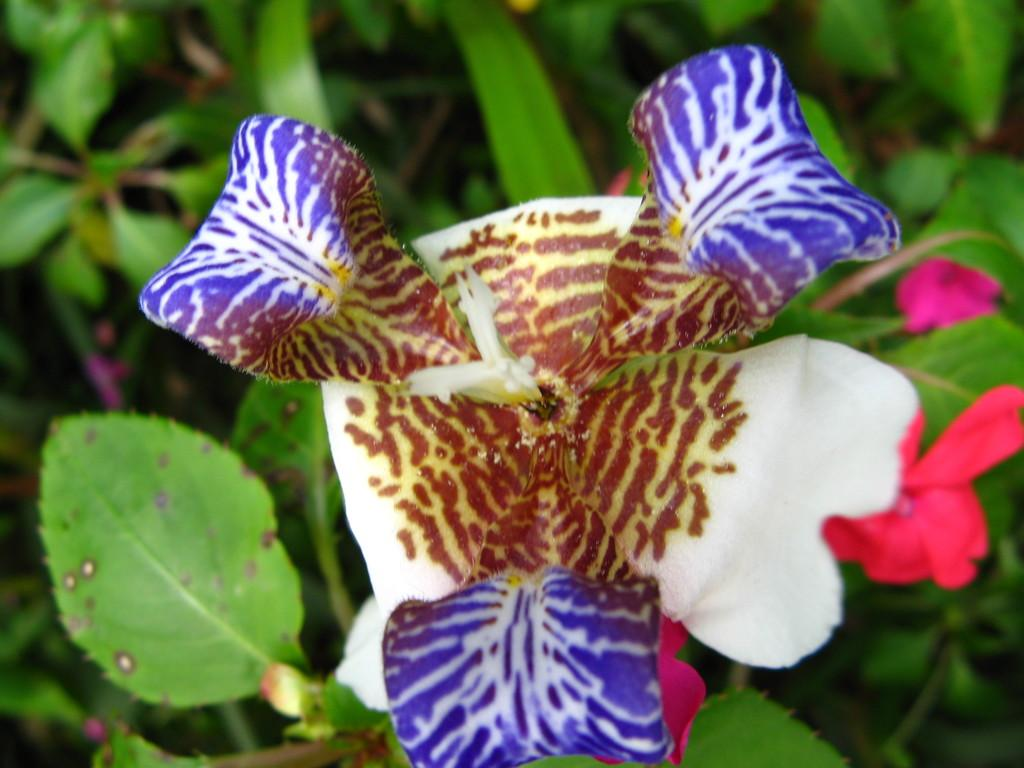What colors can be seen on the flower in the image? The flower in the image is brown, white, and purple in color. What other colors are present in the image? There are pink flowers in the image. What can be seen in the background of the image? There are plants in the background of the image. Where is the stove located in the image? There is no stove present in the image. What type of temper is the flower displaying in the image? The flower does not have a temper, as it is an inanimate object. 